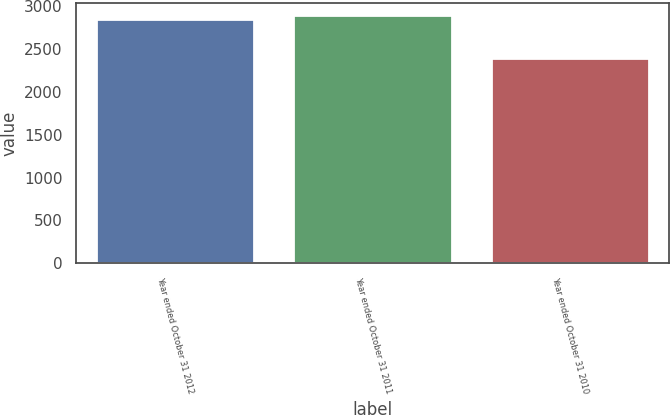Convert chart to OTSL. <chart><loc_0><loc_0><loc_500><loc_500><bar_chart><fcel>Year ended October 31 2012<fcel>Year ended October 31 2011<fcel>Year ended October 31 2010<nl><fcel>2846<fcel>2893.3<fcel>2391<nl></chart> 